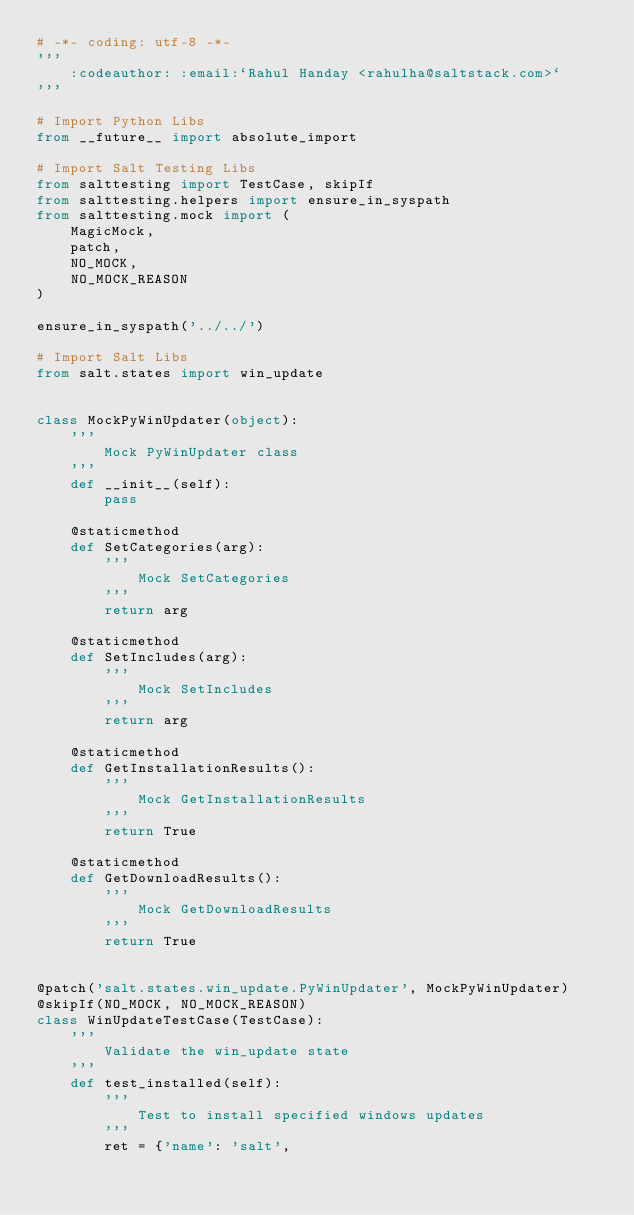<code> <loc_0><loc_0><loc_500><loc_500><_Python_># -*- coding: utf-8 -*-
'''
    :codeauthor: :email:`Rahul Handay <rahulha@saltstack.com>`
'''

# Import Python Libs
from __future__ import absolute_import

# Import Salt Testing Libs
from salttesting import TestCase, skipIf
from salttesting.helpers import ensure_in_syspath
from salttesting.mock import (
    MagicMock,
    patch,
    NO_MOCK,
    NO_MOCK_REASON
)

ensure_in_syspath('../../')

# Import Salt Libs
from salt.states import win_update


class MockPyWinUpdater(object):
    '''
        Mock PyWinUpdater class
    '''
    def __init__(self):
        pass

    @staticmethod
    def SetCategories(arg):
        '''
            Mock SetCategories
        '''
        return arg

    @staticmethod
    def SetIncludes(arg):
        '''
            Mock SetIncludes
        '''
        return arg

    @staticmethod
    def GetInstallationResults():
        '''
            Mock GetInstallationResults
        '''
        return True

    @staticmethod
    def GetDownloadResults():
        '''
            Mock GetDownloadResults
        '''
        return True


@patch('salt.states.win_update.PyWinUpdater', MockPyWinUpdater)
@skipIf(NO_MOCK, NO_MOCK_REASON)
class WinUpdateTestCase(TestCase):
    '''
        Validate the win_update state
    '''
    def test_installed(self):
        '''
            Test to install specified windows updates
        '''
        ret = {'name': 'salt',</code> 